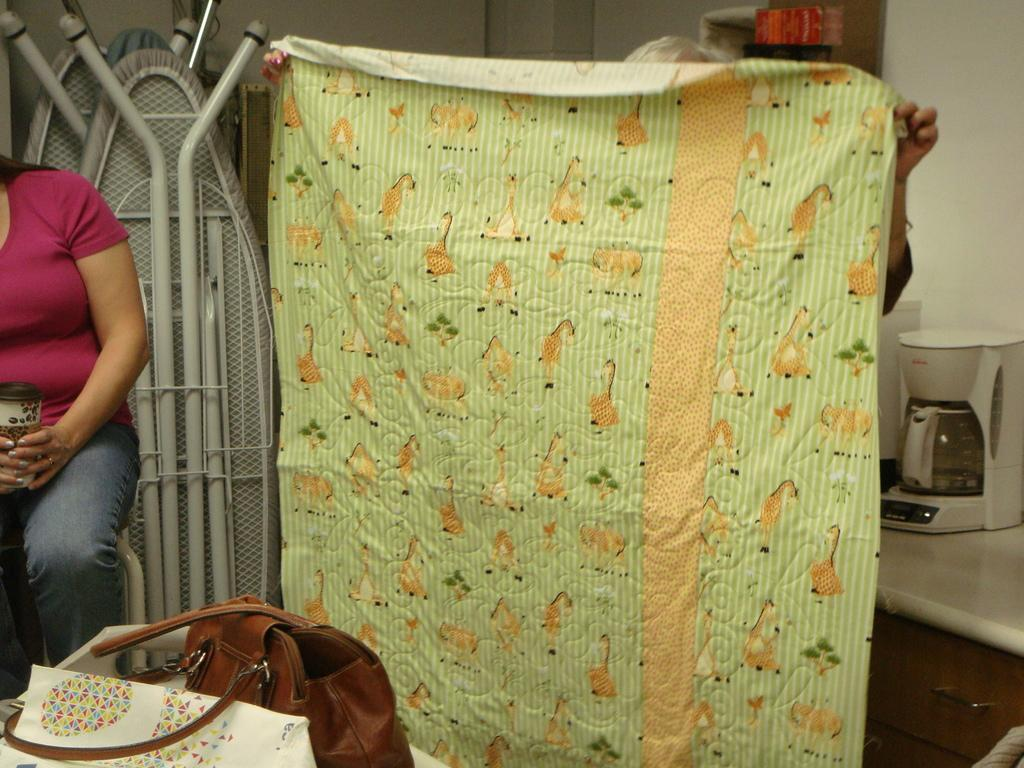Who is present in the image? There is a person in the image. What is the person holding in her hand? The person is holding a cup in her hand. What else is the person holding? The person is also holding a bag. What can be seen in the background of the image? There is a cloth and a coffee maker visible in the background. What type of collar can be seen on the person in the image? There is no collar visible on the person in the image. What division is the person working in, as seen in the image? There is no indication of a division or workplace in the image. 